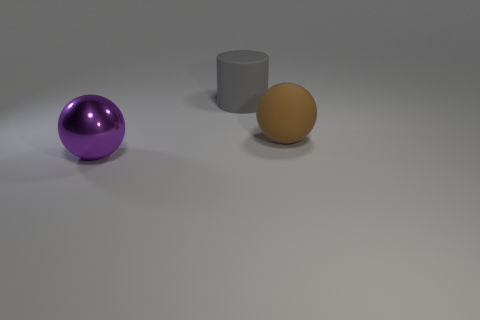What size is the object that is in front of the rubber cylinder and behind the purple shiny object?
Offer a very short reply. Large. The matte ball is what color?
Your answer should be very brief. Brown. There is a object right of the large rubber thing behind the big brown rubber thing; what number of gray rubber things are on the right side of it?
Provide a succinct answer. 0. There is a sphere that is behind the big ball that is left of the brown rubber thing; what color is it?
Your answer should be very brief. Brown. Is there a metal ball that has the same size as the rubber cylinder?
Make the answer very short. Yes. There is a large object behind the rubber object in front of the large thing that is behind the brown ball; what is it made of?
Keep it short and to the point. Rubber. There is a sphere to the right of the large gray thing; what number of large cylinders are on the left side of it?
Make the answer very short. 1. There is a ball that is on the right side of the metal thing; does it have the same size as the purple sphere?
Ensure brevity in your answer.  Yes. How many large rubber things have the same shape as the purple shiny thing?
Make the answer very short. 1. There is a gray thing; what shape is it?
Make the answer very short. Cylinder. 